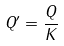Convert formula to latex. <formula><loc_0><loc_0><loc_500><loc_500>Q ^ { \prime } = \frac { Q } { K }</formula> 